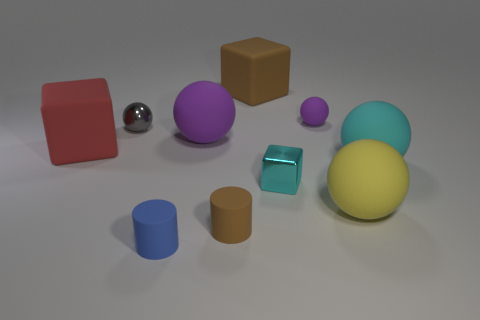There is a purple sphere behind the small metallic sphere; are there any metal blocks that are in front of it?
Your response must be concise. Yes. Are there any large yellow matte spheres?
Your response must be concise. Yes. What number of red objects are the same size as the blue rubber object?
Provide a succinct answer. 0. How many things are both on the left side of the cyan cube and on the right side of the small metallic sphere?
Provide a short and direct response. 4. Is the size of the matte cylinder to the right of the blue matte object the same as the large cyan matte thing?
Your response must be concise. No. Are there any large balls of the same color as the metal cube?
Offer a terse response. Yes. There is a blue cylinder that is the same material as the small purple thing; what is its size?
Ensure brevity in your answer.  Small. Are there more brown blocks in front of the yellow rubber sphere than things in front of the large purple ball?
Ensure brevity in your answer.  No. How many other objects are there of the same material as the gray sphere?
Ensure brevity in your answer.  1. Do the purple thing that is left of the tiny cyan block and the gray thing have the same material?
Offer a very short reply. No. 